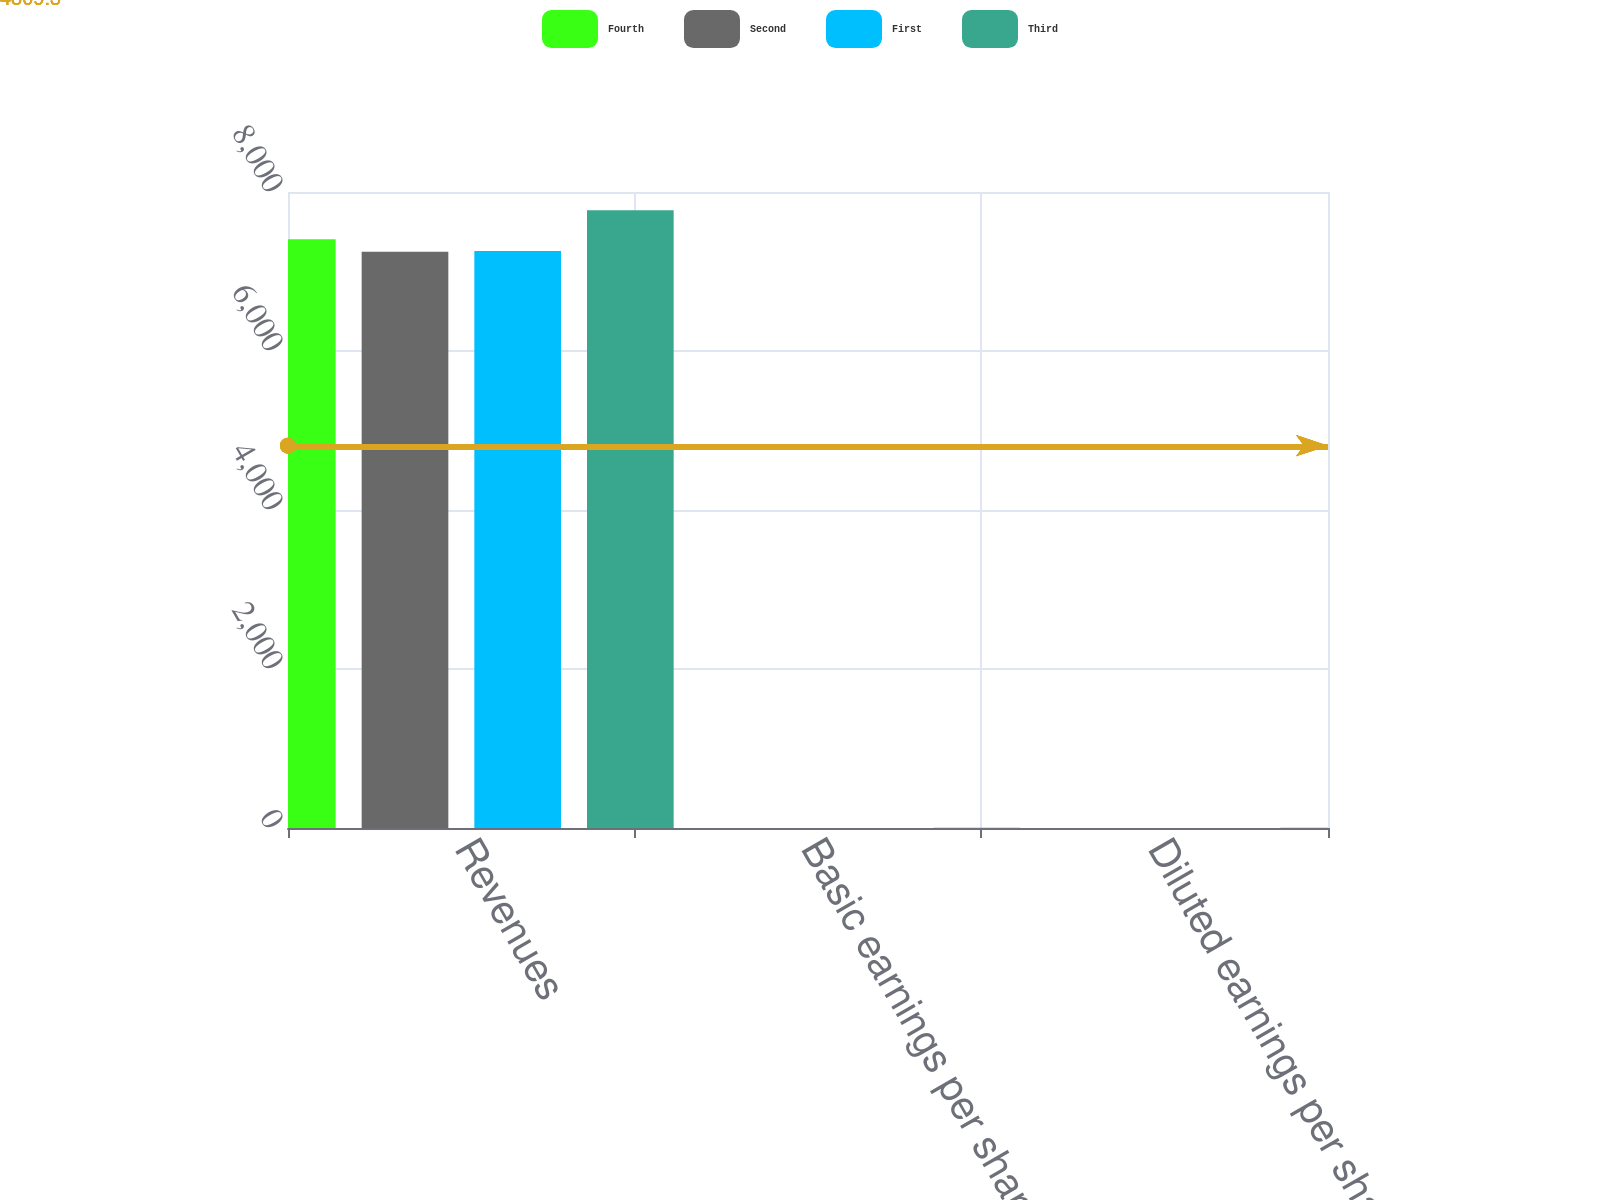<chart> <loc_0><loc_0><loc_500><loc_500><stacked_bar_chart><ecel><fcel>Revenues<fcel>Basic earnings per share<fcel>Diluted earnings per share<nl><fcel>Fourth<fcel>7406<fcel>0.54<fcel>0.52<nl><fcel>Second<fcel>7249<fcel>0.44<fcel>0.43<nl><fcel>First<fcel>7258<fcel>0.12<fcel>0.11<nl><fcel>Third<fcel>7769<fcel>4.43<fcel>4.25<nl></chart> 